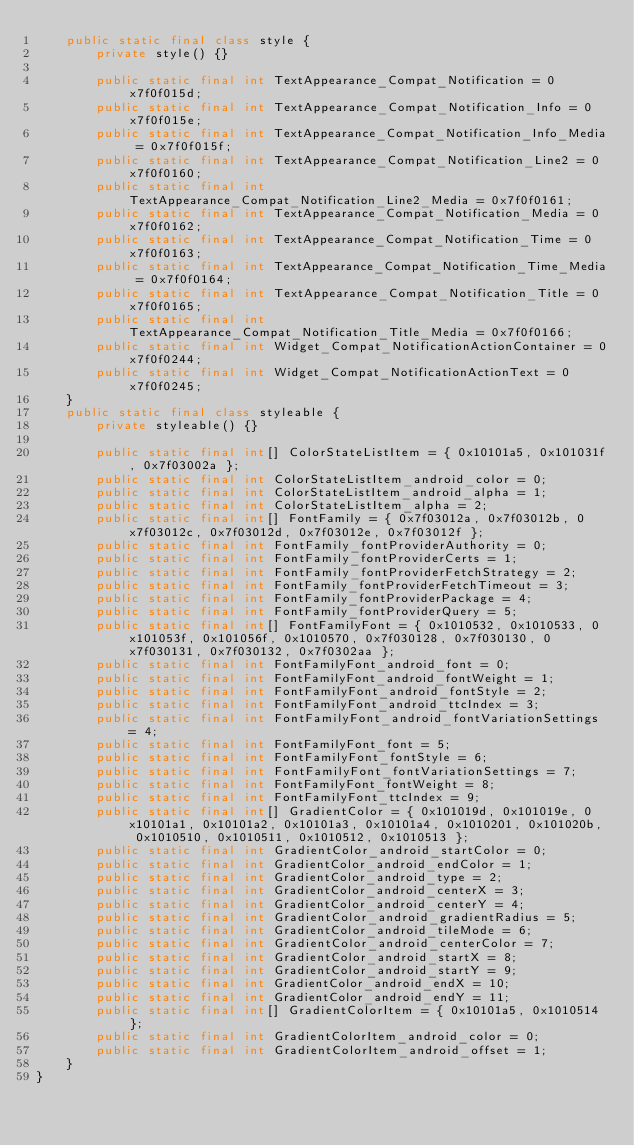<code> <loc_0><loc_0><loc_500><loc_500><_Java_>    public static final class style {
        private style() {}

        public static final int TextAppearance_Compat_Notification = 0x7f0f015d;
        public static final int TextAppearance_Compat_Notification_Info = 0x7f0f015e;
        public static final int TextAppearance_Compat_Notification_Info_Media = 0x7f0f015f;
        public static final int TextAppearance_Compat_Notification_Line2 = 0x7f0f0160;
        public static final int TextAppearance_Compat_Notification_Line2_Media = 0x7f0f0161;
        public static final int TextAppearance_Compat_Notification_Media = 0x7f0f0162;
        public static final int TextAppearance_Compat_Notification_Time = 0x7f0f0163;
        public static final int TextAppearance_Compat_Notification_Time_Media = 0x7f0f0164;
        public static final int TextAppearance_Compat_Notification_Title = 0x7f0f0165;
        public static final int TextAppearance_Compat_Notification_Title_Media = 0x7f0f0166;
        public static final int Widget_Compat_NotificationActionContainer = 0x7f0f0244;
        public static final int Widget_Compat_NotificationActionText = 0x7f0f0245;
    }
    public static final class styleable {
        private styleable() {}

        public static final int[] ColorStateListItem = { 0x10101a5, 0x101031f, 0x7f03002a };
        public static final int ColorStateListItem_android_color = 0;
        public static final int ColorStateListItem_android_alpha = 1;
        public static final int ColorStateListItem_alpha = 2;
        public static final int[] FontFamily = { 0x7f03012a, 0x7f03012b, 0x7f03012c, 0x7f03012d, 0x7f03012e, 0x7f03012f };
        public static final int FontFamily_fontProviderAuthority = 0;
        public static final int FontFamily_fontProviderCerts = 1;
        public static final int FontFamily_fontProviderFetchStrategy = 2;
        public static final int FontFamily_fontProviderFetchTimeout = 3;
        public static final int FontFamily_fontProviderPackage = 4;
        public static final int FontFamily_fontProviderQuery = 5;
        public static final int[] FontFamilyFont = { 0x1010532, 0x1010533, 0x101053f, 0x101056f, 0x1010570, 0x7f030128, 0x7f030130, 0x7f030131, 0x7f030132, 0x7f0302aa };
        public static final int FontFamilyFont_android_font = 0;
        public static final int FontFamilyFont_android_fontWeight = 1;
        public static final int FontFamilyFont_android_fontStyle = 2;
        public static final int FontFamilyFont_android_ttcIndex = 3;
        public static final int FontFamilyFont_android_fontVariationSettings = 4;
        public static final int FontFamilyFont_font = 5;
        public static final int FontFamilyFont_fontStyle = 6;
        public static final int FontFamilyFont_fontVariationSettings = 7;
        public static final int FontFamilyFont_fontWeight = 8;
        public static final int FontFamilyFont_ttcIndex = 9;
        public static final int[] GradientColor = { 0x101019d, 0x101019e, 0x10101a1, 0x10101a2, 0x10101a3, 0x10101a4, 0x1010201, 0x101020b, 0x1010510, 0x1010511, 0x1010512, 0x1010513 };
        public static final int GradientColor_android_startColor = 0;
        public static final int GradientColor_android_endColor = 1;
        public static final int GradientColor_android_type = 2;
        public static final int GradientColor_android_centerX = 3;
        public static final int GradientColor_android_centerY = 4;
        public static final int GradientColor_android_gradientRadius = 5;
        public static final int GradientColor_android_tileMode = 6;
        public static final int GradientColor_android_centerColor = 7;
        public static final int GradientColor_android_startX = 8;
        public static final int GradientColor_android_startY = 9;
        public static final int GradientColor_android_endX = 10;
        public static final int GradientColor_android_endY = 11;
        public static final int[] GradientColorItem = { 0x10101a5, 0x1010514 };
        public static final int GradientColorItem_android_color = 0;
        public static final int GradientColorItem_android_offset = 1;
    }
}
</code> 